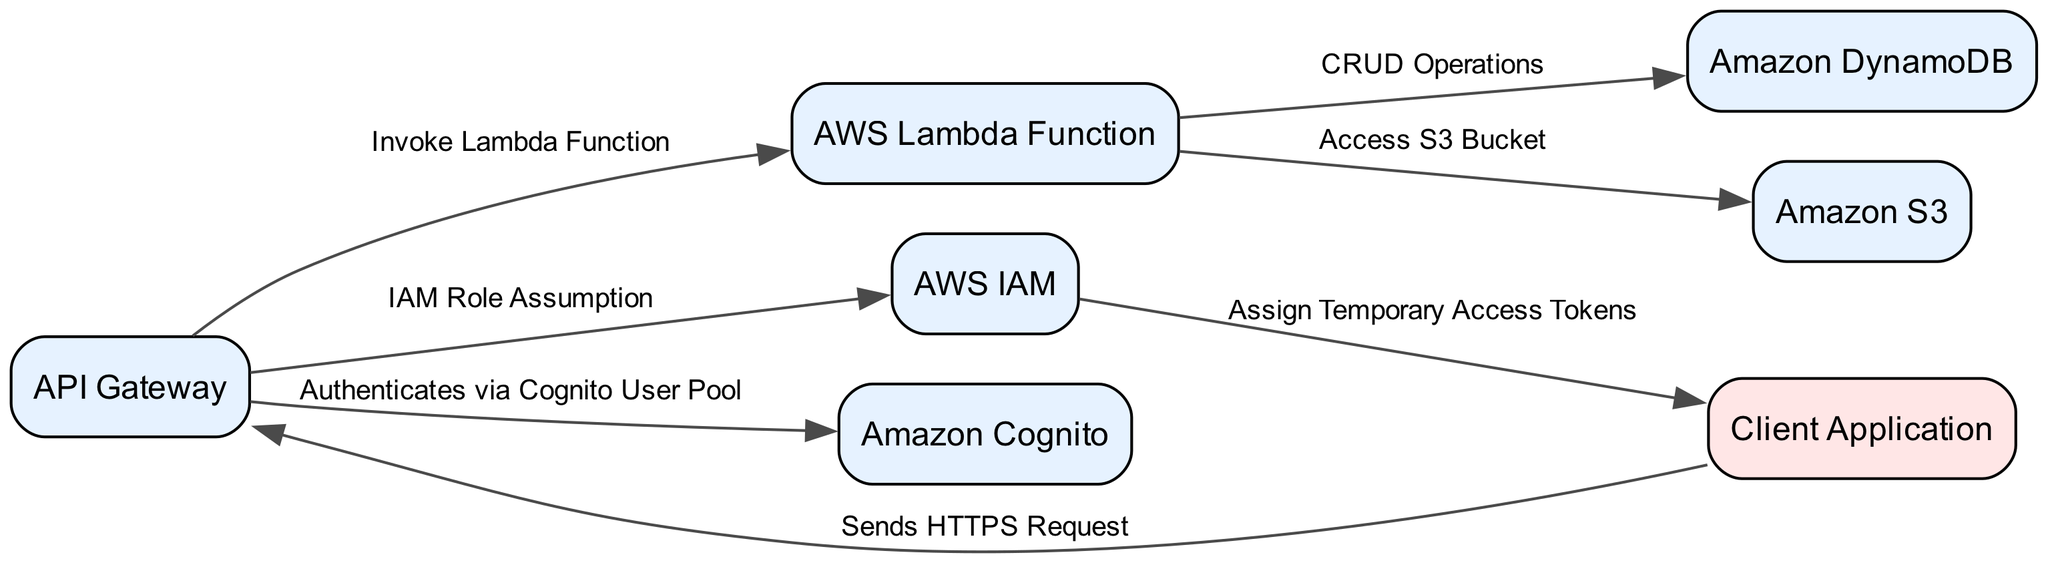What is the label of the node connected to the Client? The Client node is connected to the API Gateway. This relationship is explicitly labeled in the diagram.
Answer: API Gateway How many services are represented in the diagram? By counting the nodes classified as services, there are six services: API Gateway, AWS Lambda Function, AWS IAM, Amazon Cognito, Amazon DynamoDB, and Amazon S3.
Answer: 6 What type of relationship exists between the API Gateway and Cognito? The diagram indicates an authentication relationship from API Gateway to Cognito, specifically noted as "Authenticates via Cognito User Pool," which clarifies the nature of their connection.
Answer: Authenticates via Cognito User Pool Which entity receives temporary access tokens from IAM? The IAM node is connected to the Client node with the label "Assign Temporary Access Tokens," indicating that the Client receives these tokens from IAM.
Answer: Client What operations can the Lambda function perform on DynamoDB? The diagram specifies that the Lambda function performs "CRUD Operations" on DynamoDB, implying it can create, read, update, and delete data.
Answer: CRUD Operations Which node sends requests to the API Gateway? The diagram shows a connection where the Client node sends HTTPS requests, clearly stating who initiates the communication with the API Gateway.
Answer: Client Application How many edges connect the Lambda function to other services? By examining the edges, the Lambda function connects to two other services: DynamoDB and S3, leading to a total count of two edges.
Answer: 2 What is the first step that occurs when the Client interacts with the API Gateway? The diagram shows that the Client sends an HTTPS request to the API Gateway, marking it as the initial step in their interaction.
Answer: Sends HTTPS Request 